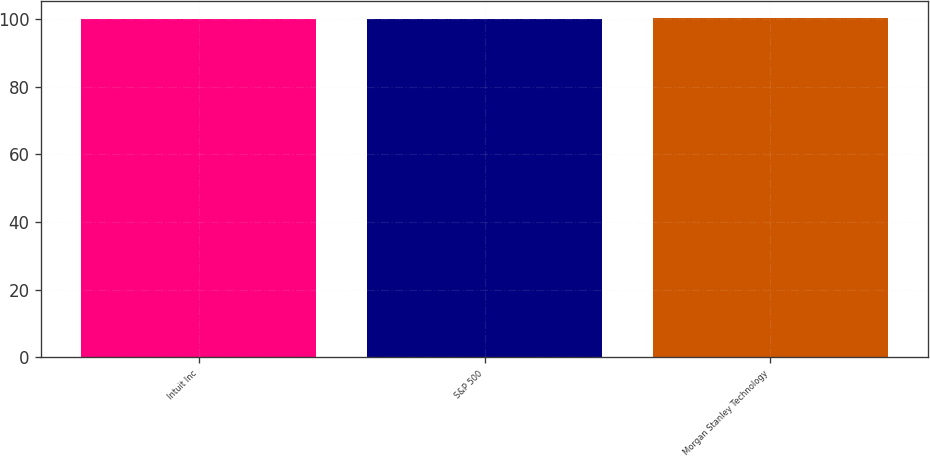Convert chart to OTSL. <chart><loc_0><loc_0><loc_500><loc_500><bar_chart><fcel>Intuit Inc<fcel>S&P 500<fcel>Morgan Stanley Technology<nl><fcel>100<fcel>100.1<fcel>100.2<nl></chart> 